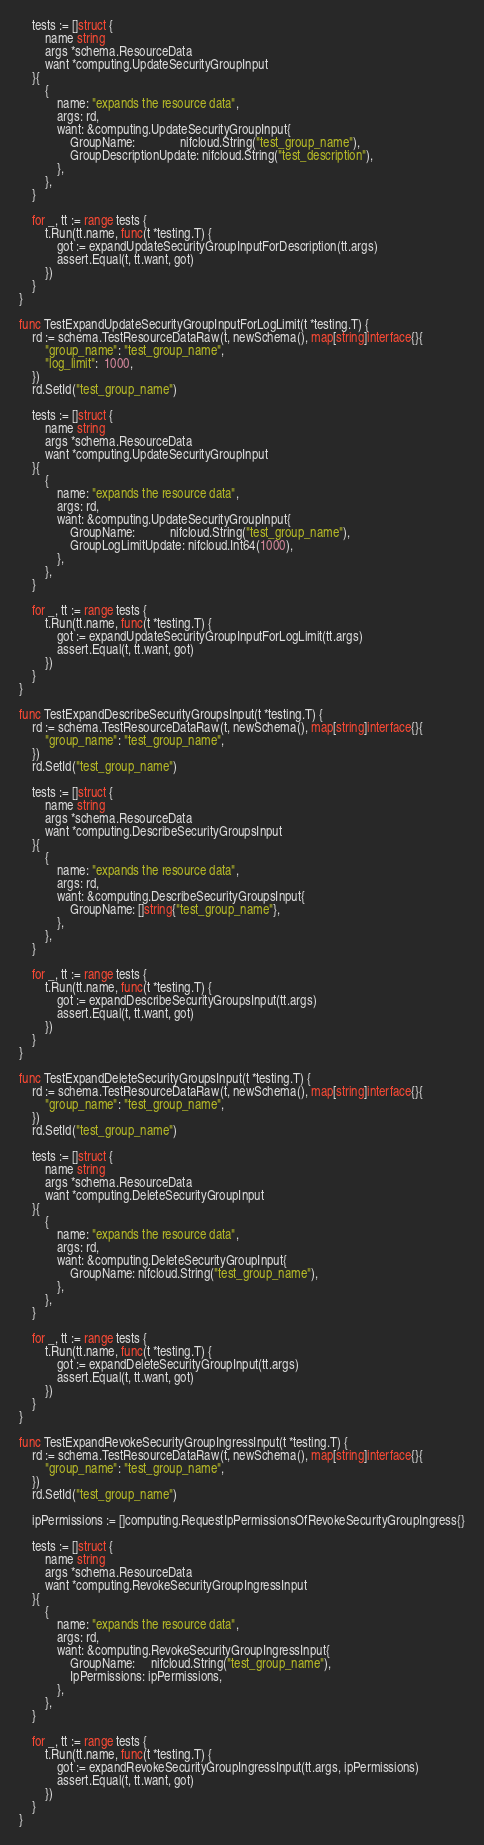Convert code to text. <code><loc_0><loc_0><loc_500><loc_500><_Go_>
	tests := []struct {
		name string
		args *schema.ResourceData
		want *computing.UpdateSecurityGroupInput
	}{
		{
			name: "expands the resource data",
			args: rd,
			want: &computing.UpdateSecurityGroupInput{
				GroupName:              nifcloud.String("test_group_name"),
				GroupDescriptionUpdate: nifcloud.String("test_description"),
			},
		},
	}

	for _, tt := range tests {
		t.Run(tt.name, func(t *testing.T) {
			got := expandUpdateSecurityGroupInputForDescription(tt.args)
			assert.Equal(t, tt.want, got)
		})
	}
}

func TestExpandUpdateSecurityGroupInputForLogLimit(t *testing.T) {
	rd := schema.TestResourceDataRaw(t, newSchema(), map[string]interface{}{
		"group_name": "test_group_name",
		"log_limit":  1000,
	})
	rd.SetId("test_group_name")

	tests := []struct {
		name string
		args *schema.ResourceData
		want *computing.UpdateSecurityGroupInput
	}{
		{
			name: "expands the resource data",
			args: rd,
			want: &computing.UpdateSecurityGroupInput{
				GroupName:           nifcloud.String("test_group_name"),
				GroupLogLimitUpdate: nifcloud.Int64(1000),
			},
		},
	}

	for _, tt := range tests {
		t.Run(tt.name, func(t *testing.T) {
			got := expandUpdateSecurityGroupInputForLogLimit(tt.args)
			assert.Equal(t, tt.want, got)
		})
	}
}

func TestExpandDescribeSecurityGroupsInput(t *testing.T) {
	rd := schema.TestResourceDataRaw(t, newSchema(), map[string]interface{}{
		"group_name": "test_group_name",
	})
	rd.SetId("test_group_name")

	tests := []struct {
		name string
		args *schema.ResourceData
		want *computing.DescribeSecurityGroupsInput
	}{
		{
			name: "expands the resource data",
			args: rd,
			want: &computing.DescribeSecurityGroupsInput{
				GroupName: []string{"test_group_name"},
			},
		},
	}

	for _, tt := range tests {
		t.Run(tt.name, func(t *testing.T) {
			got := expandDescribeSecurityGroupsInput(tt.args)
			assert.Equal(t, tt.want, got)
		})
	}
}

func TestExpandDeleteSecurityGroupsInput(t *testing.T) {
	rd := schema.TestResourceDataRaw(t, newSchema(), map[string]interface{}{
		"group_name": "test_group_name",
	})
	rd.SetId("test_group_name")

	tests := []struct {
		name string
		args *schema.ResourceData
		want *computing.DeleteSecurityGroupInput
	}{
		{
			name: "expands the resource data",
			args: rd,
			want: &computing.DeleteSecurityGroupInput{
				GroupName: nifcloud.String("test_group_name"),
			},
		},
	}

	for _, tt := range tests {
		t.Run(tt.name, func(t *testing.T) {
			got := expandDeleteSecurityGroupInput(tt.args)
			assert.Equal(t, tt.want, got)
		})
	}
}

func TestExpandRevokeSecurityGroupIngressInput(t *testing.T) {
	rd := schema.TestResourceDataRaw(t, newSchema(), map[string]interface{}{
		"group_name": "test_group_name",
	})
	rd.SetId("test_group_name")

	ipPermissions := []computing.RequestIpPermissionsOfRevokeSecurityGroupIngress{}

	tests := []struct {
		name string
		args *schema.ResourceData
		want *computing.RevokeSecurityGroupIngressInput
	}{
		{
			name: "expands the resource data",
			args: rd,
			want: &computing.RevokeSecurityGroupIngressInput{
				GroupName:     nifcloud.String("test_group_name"),
				IpPermissions: ipPermissions,
			},
		},
	}

	for _, tt := range tests {
		t.Run(tt.name, func(t *testing.T) {
			got := expandRevokeSecurityGroupIngressInput(tt.args, ipPermissions)
			assert.Equal(t, tt.want, got)
		})
	}
}
</code> 